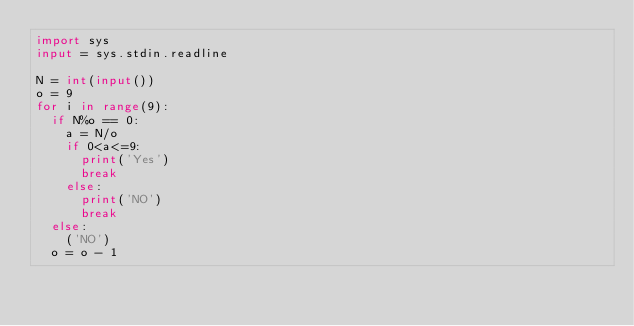<code> <loc_0><loc_0><loc_500><loc_500><_Python_>import sys
input = sys.stdin.readline

N = int(input())
o = 9
for i in range(9):
  if N%o == 0:
    a = N/o
    if 0<a<=9:
      print('Yes')
      break
    else:
      print('NO')
      break
  else:
    ('NO')
  o = o - 1</code> 